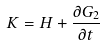Convert formula to latex. <formula><loc_0><loc_0><loc_500><loc_500>K = H + \frac { \partial G _ { 2 } } { \partial t }</formula> 